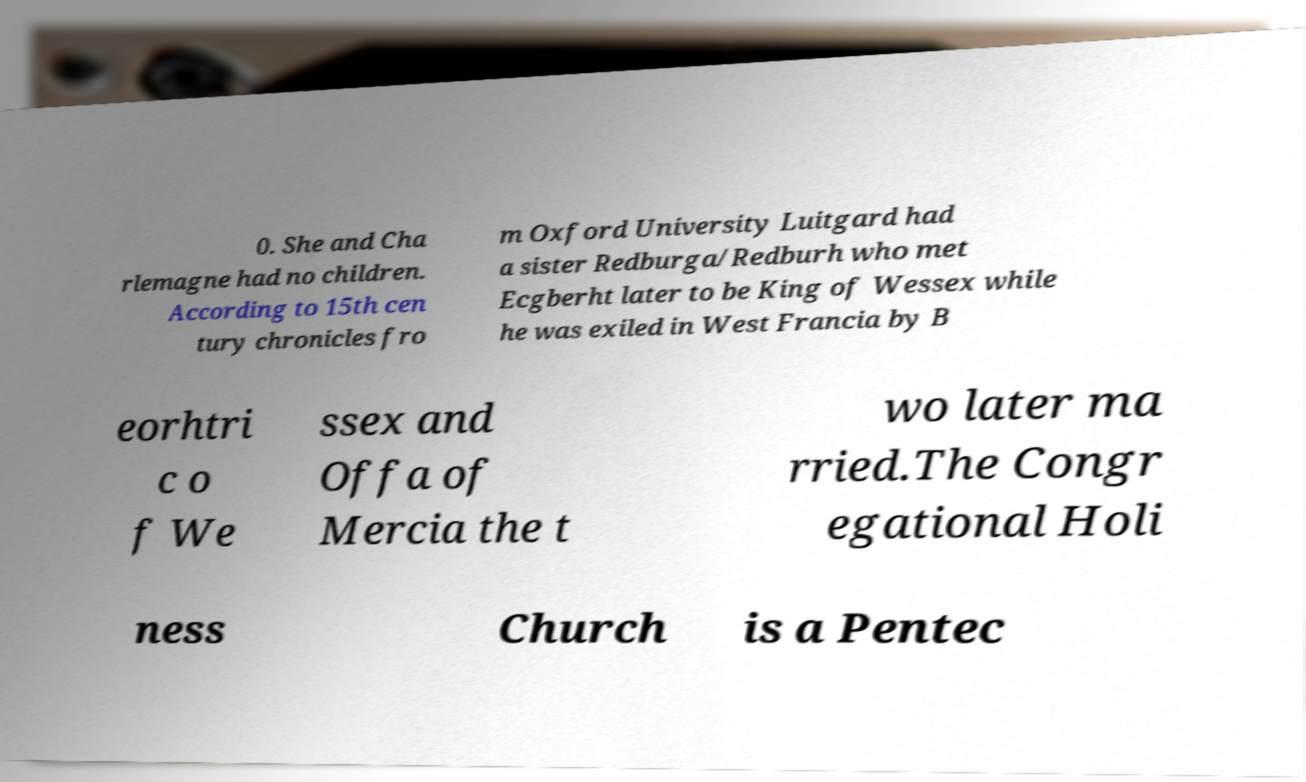What messages or text are displayed in this image? I need them in a readable, typed format. 0. She and Cha rlemagne had no children. According to 15th cen tury chronicles fro m Oxford University Luitgard had a sister Redburga/Redburh who met Ecgberht later to be King of Wessex while he was exiled in West Francia by B eorhtri c o f We ssex and Offa of Mercia the t wo later ma rried.The Congr egational Holi ness Church is a Pentec 